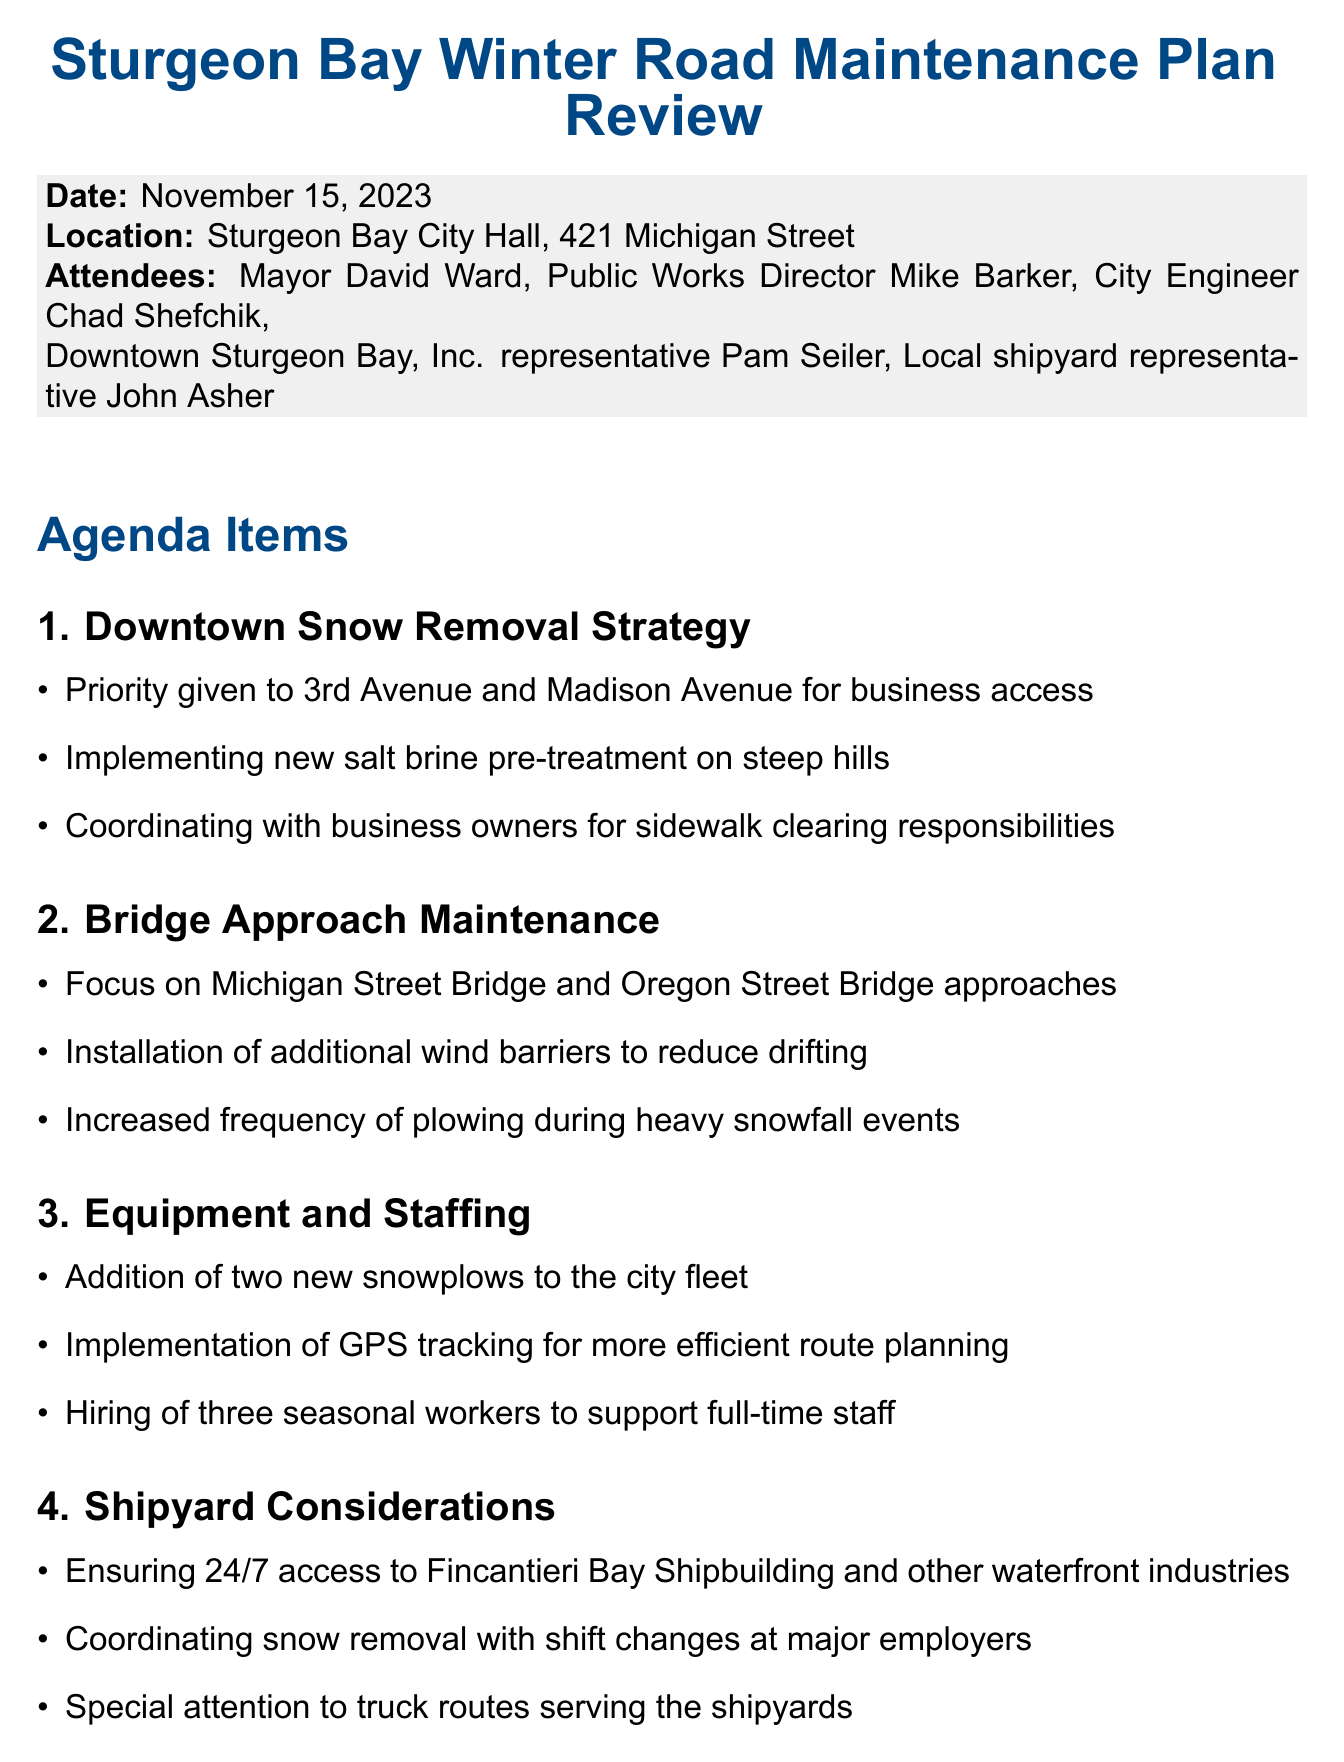What is the date of the meeting? The date of the meeting is specified in the document header.
Answer: November 15, 2023 Who is the Public Works Director? The document lists the attendees and their titles, identifying the Public Works Director.
Answer: Mike Barker What strategy is employed on steep hills? The document mentions specific strategies under the Downtown Snow Removal Strategy section.
Answer: Salt brine pre-treatment Which bridges are focused on for approach maintenance? The document outlines the bridges under the Bridge Approach Maintenance section.
Answer: Michigan Street Bridge and Oregon Street Bridge How many new snowplows will be added to the fleet? The document specifies the addition of equipment in the Equipment and Staffing section.
Answer: Two new snowplows What will be updated by the City Engineer? The action items include specific updates to be made by the City Engineer, listed in the action items section.
Answer: Snow route maps Why is snow removal coordinated with shift changes? The document highlights a specific consideration for logistics during snow removal relevant to key industries.
Answer: To ensure 24/7 access to Fincantieri Bay Shipbuilding What is created for communication with residents? The Public Communication section mentions specific initiatives aimed at improving resident engagement.
Answer: Winter maintenance hotline 